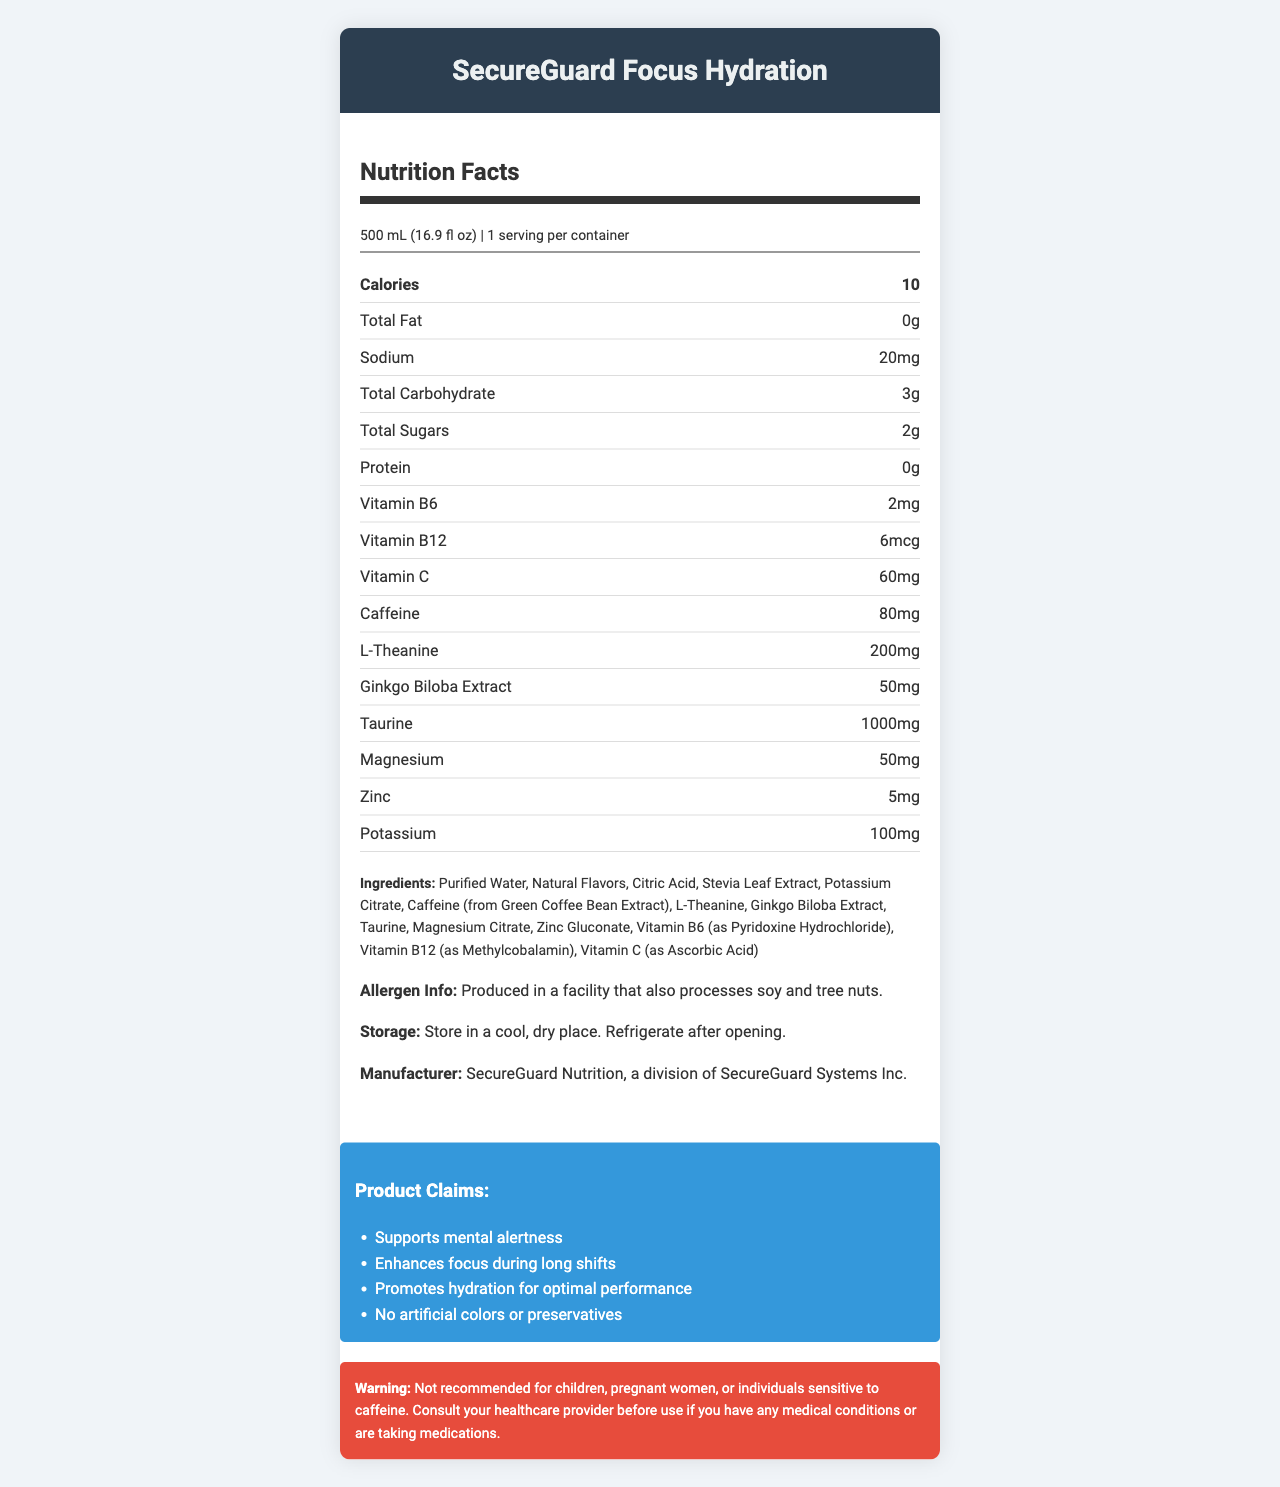What is the serving size of SecureGuard Focus Hydration? The serving size is clearly listed at the top under the Nutrition Facts section.
Answer: 500 mL (16.9 fl oz) How much caffeine is in a serving of SecureGuard Focus Hydration? The amount of caffeine per serving is listed under the nutrient information section.
Answer: 80mg What is the total carbohydrate content per serving? The total carbohydrate content is listed under the nutrient row for total carbohydrates.
Answer: 3g List two minerals found in SecureGuard Focus Hydration. Both magnesium and zinc are listed in the nutrient information section.
Answer: Magnesium and Zinc What are the key ingredients in SecureGuard Focus Hydration? All key ingredients are listed in the ingredients section.
Answer: Purified Water, Natural Flavors, Citric Acid, Stevia Leaf Extract, Potassium Citrate, Caffeine (from Green Coffee Bean Extract), L-Theanine, Ginkgo Biloba Extract, Taurine, Magnesium Citrate, Zinc Gluconate, Vitamin B6 (as Pyridoxine Hydrochloride), Vitamin B12 (as Methylcobalamin), Vitamin C (as Ascorbic Acid) What is the main claim of SecureGuard Focus Hydration regarding mental performance? A. Enhances physical strength B. Supports mental alertness C. Aids in weight loss The product claims section states "Supports mental alertness".
Answer: B How many calories are in one serving of SecureGuard Focus Hydration? A. 0 calories B. 5 calories C. 10 calories D. 15 calories The calories per serving is listed as 10.
Answer: C Which vitamin is not present in SecureGuard Focus Hydration? A. Vitamin A B. Vitamin B6 C. Vitamin B12 D. Vitamin C The document lists Vitamin B6, Vitamin B12, and Vitamin C, but there is no mention of Vitamin A.
Answer: A Is the product suitable for children and pregnant women? The warning section states that the product is not recommended for children or pregnant women.
Answer: No Summarize the primary features of SecureGuard Focus Hydration. The main features are derived from information spread across all sections, including nutrition facts, ingredients, and product claims.
Answer: SecureGuard Focus Hydration is a vitamin-fortified beverage designed to support mental alertness and enhance focus during long shifts. It promotes hydration with a low calorie count, contains no artificial colors or preservatives, and includes ingredients such as caffeine, L-Theanine, Ginkgo Biloba Extract, taurine, and various vitamins and minerals. It has a gentle warning for certain groups of people, suggesting consultation with a healthcare provider where necessary. What is the Total Sugars content per bottle? The Total Sugars content is clearly listed under the nutrient information section for Total Sugars.
Answer: 2g Would SecureGuard Focus Hydration be considered allergen-free? The allergen information states that it is produced in a facility that also processes soy and tree nuts.
Answer: No Can the document tell us the price of SecureGuard Focus Hydration? The document does not provide any information regarding the price.
Answer: Not enough information 